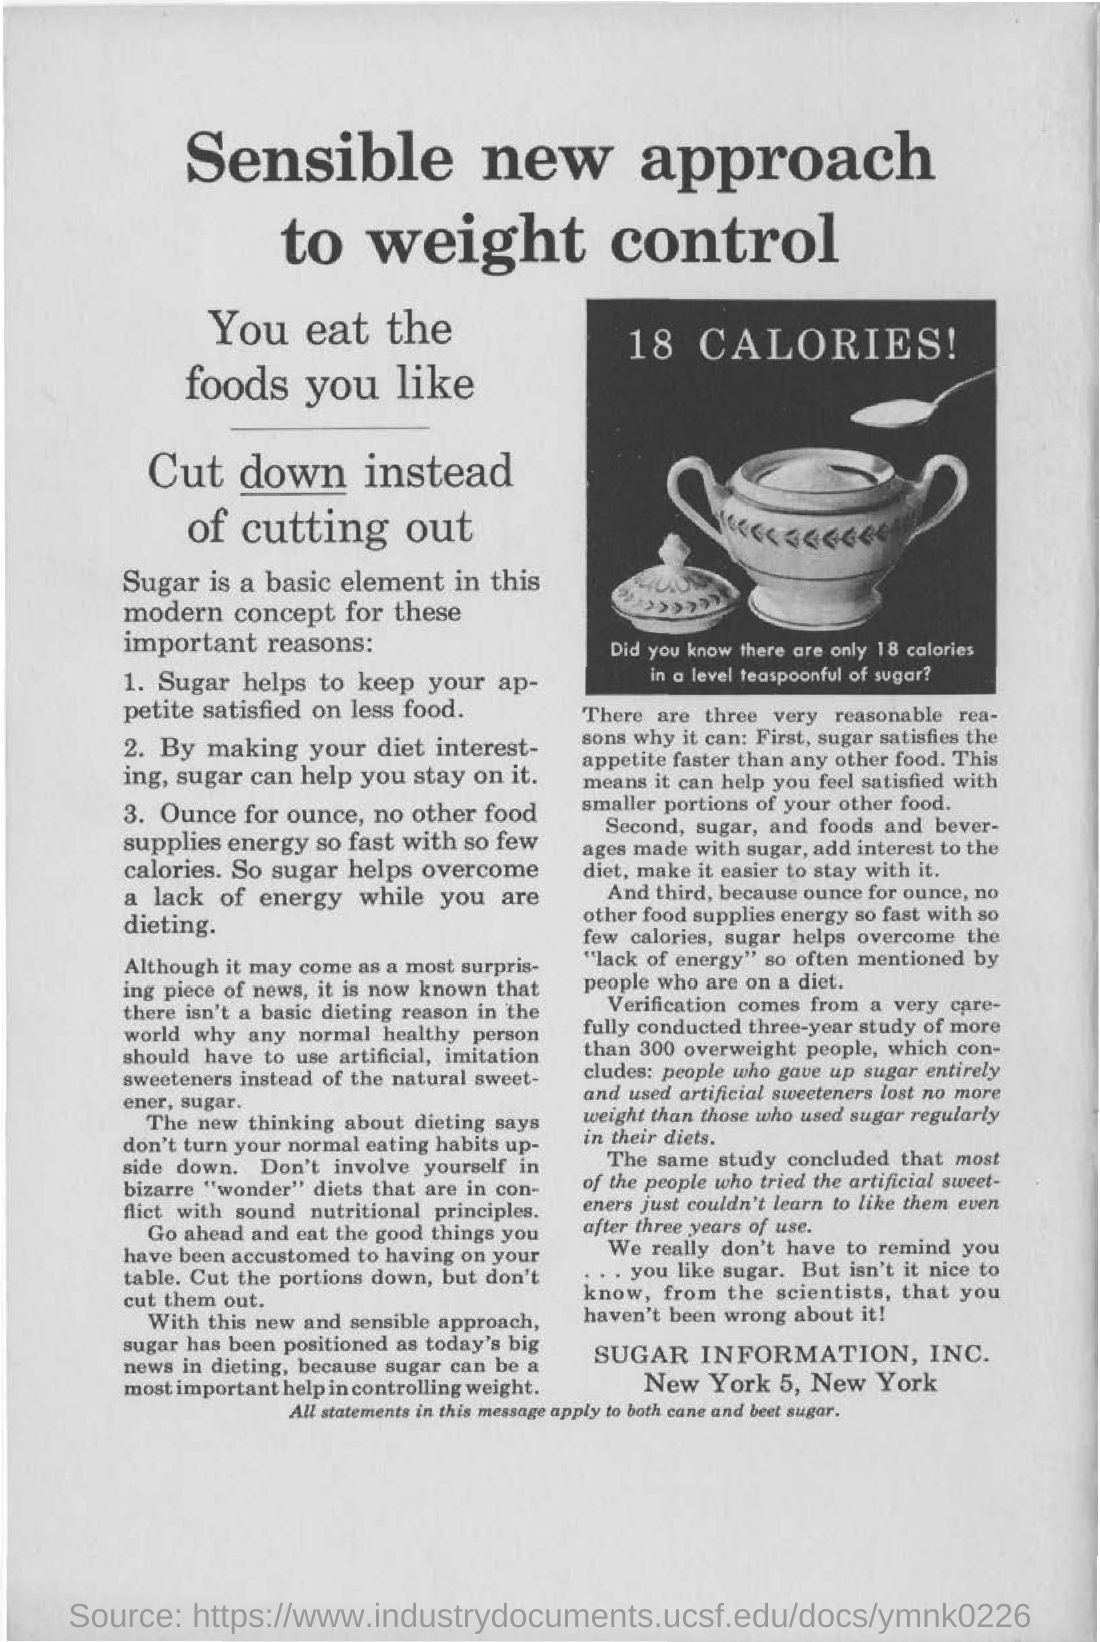What is the main heading of the document?
Give a very brief answer. Sensible new approach to weight control. How many calories are there in a level teaspoonful of sugar?
Give a very brief answer. 18 CALORIES. What is the number of calories written in the image?
Give a very brief answer. 18 CALORIES!. What is the main heading in bold letters written in the document ?
Your answer should be compact. Sensible new approach to weight control. 